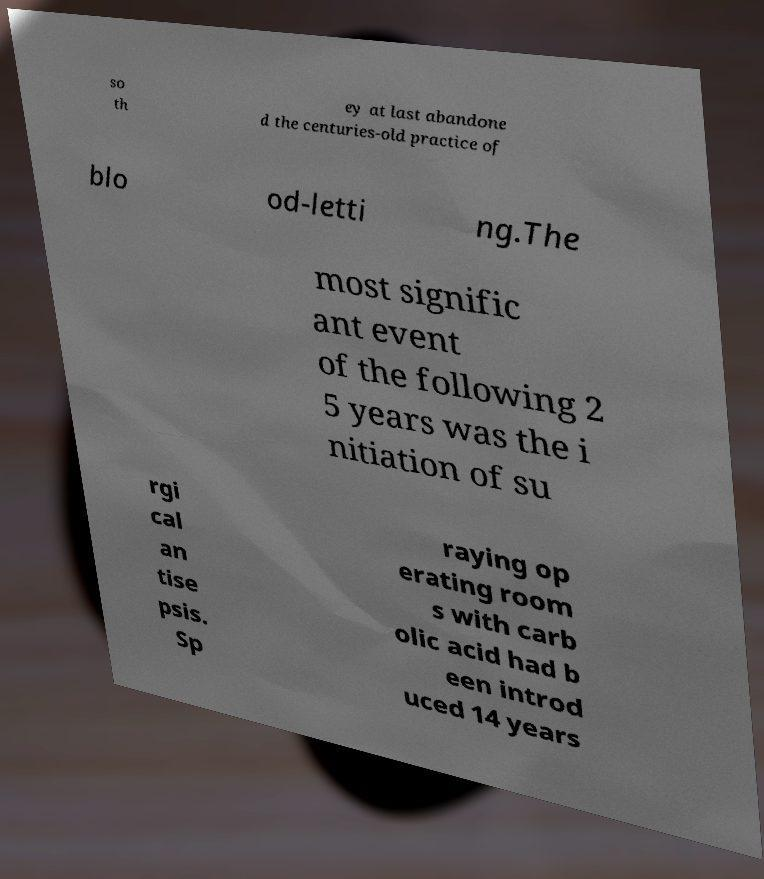Could you assist in decoding the text presented in this image and type it out clearly? so th ey at last abandone d the centuries-old practice of blo od-letti ng.The most signific ant event of the following 2 5 years was the i nitiation of su rgi cal an tise psis. Sp raying op erating room s with carb olic acid had b een introd uced 14 years 